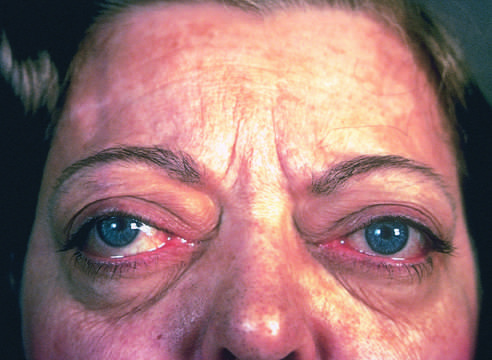do most scars add to the protuberant appearance of the eyes in graves disease?
Answer the question using a single word or phrase. No 